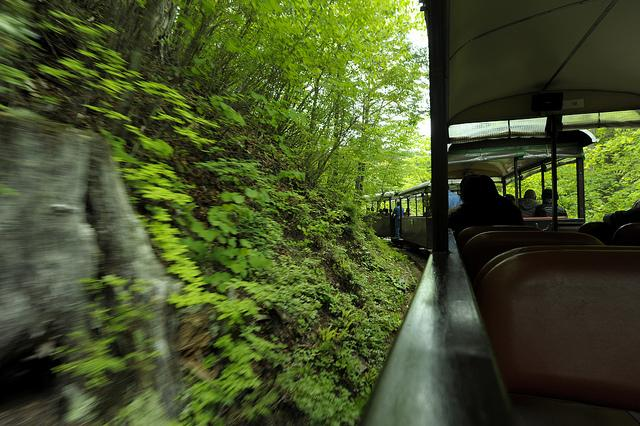If you stuck your hand out the side what would happen? touch leaves 